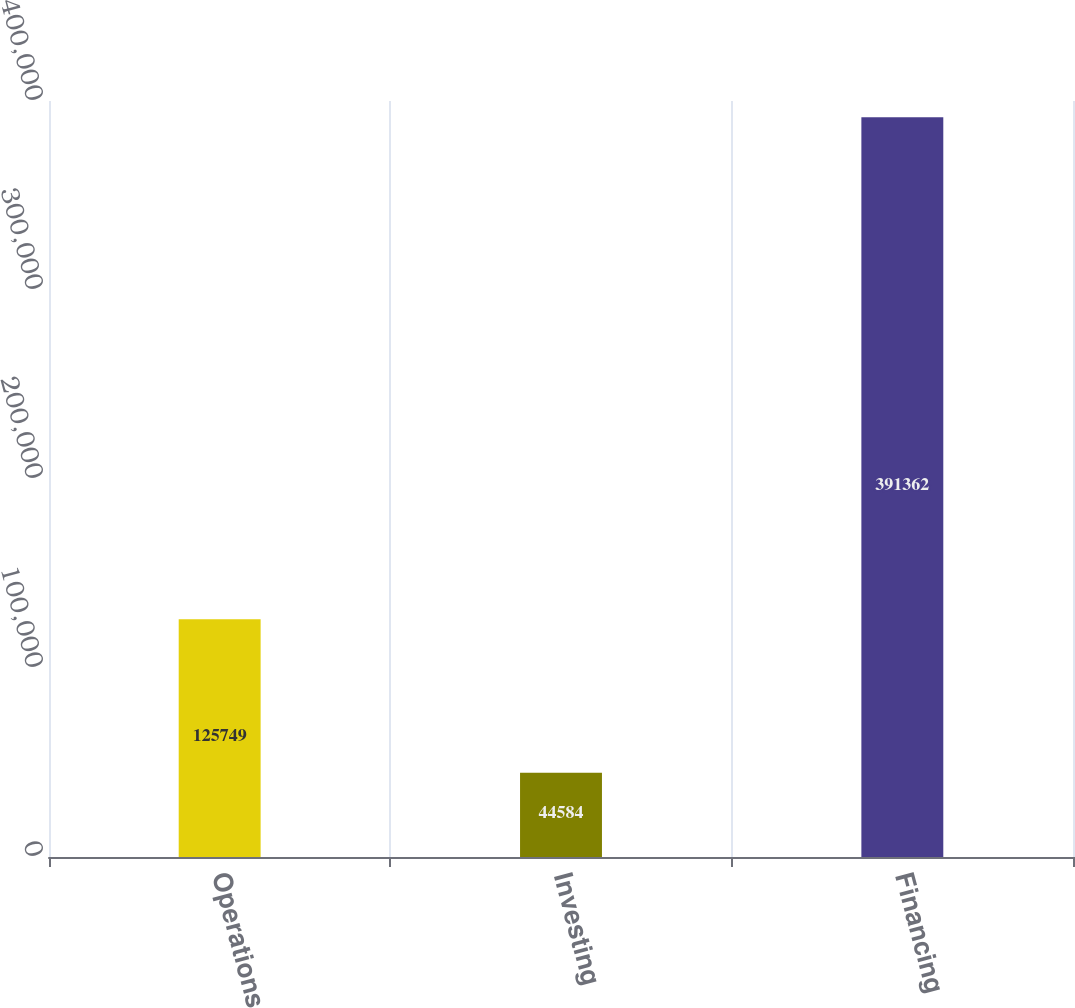<chart> <loc_0><loc_0><loc_500><loc_500><bar_chart><fcel>Operations<fcel>Investing<fcel>Financing<nl><fcel>125749<fcel>44584<fcel>391362<nl></chart> 